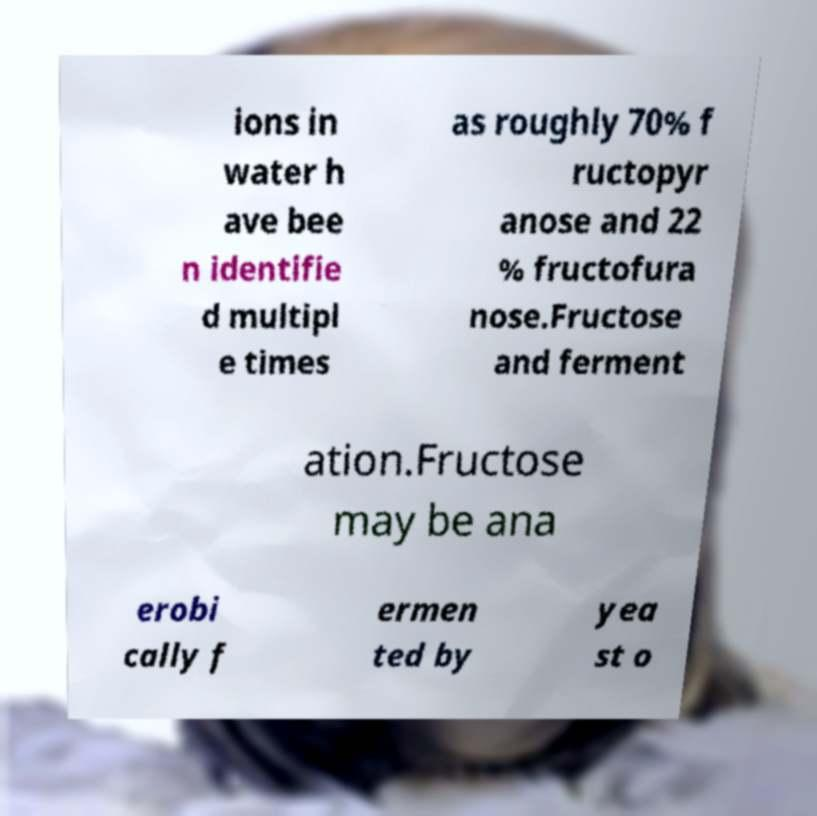Can you accurately transcribe the text from the provided image for me? ions in water h ave bee n identifie d multipl e times as roughly 70% f ructopyr anose and 22 % fructofura nose.Fructose and ferment ation.Fructose may be ana erobi cally f ermen ted by yea st o 